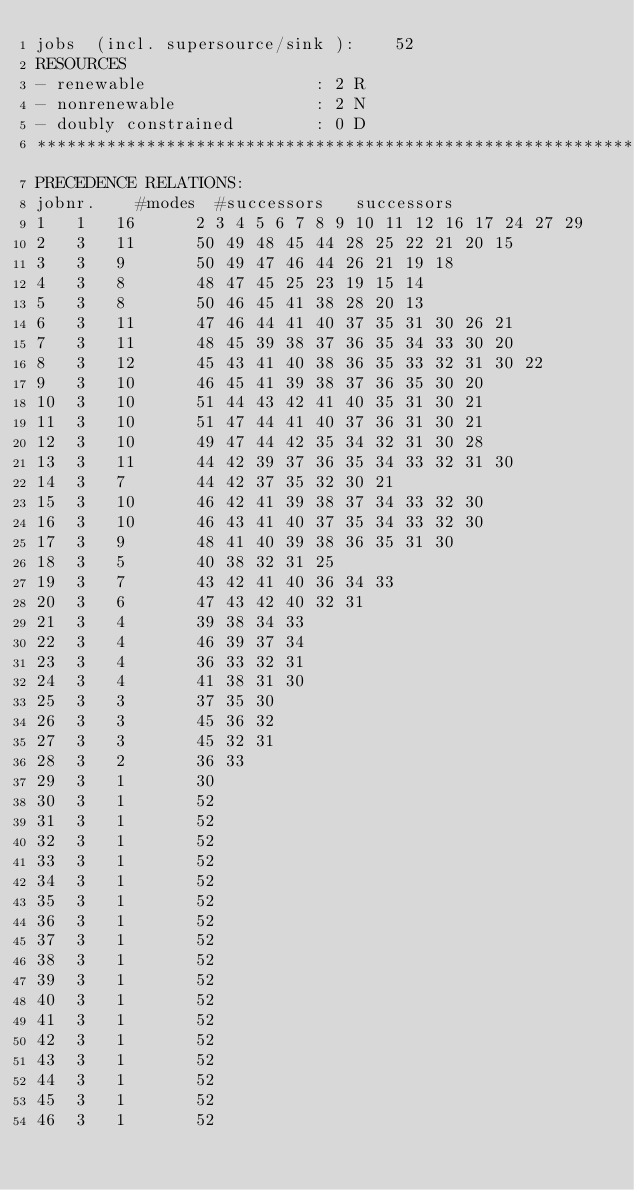<code> <loc_0><loc_0><loc_500><loc_500><_ObjectiveC_>jobs  (incl. supersource/sink ):	52
RESOURCES
- renewable                 : 2 R
- nonrenewable              : 2 N
- doubly constrained        : 0 D
************************************************************************
PRECEDENCE RELATIONS:
jobnr.    #modes  #successors   successors
1	1	16		2 3 4 5 6 7 8 9 10 11 12 16 17 24 27 29 
2	3	11		50 49 48 45 44 28 25 22 21 20 15 
3	3	9		50 49 47 46 44 26 21 19 18 
4	3	8		48 47 45 25 23 19 15 14 
5	3	8		50 46 45 41 38 28 20 13 
6	3	11		47 46 44 41 40 37 35 31 30 26 21 
7	3	11		48 45 39 38 37 36 35 34 33 30 20 
8	3	12		45 43 41 40 38 36 35 33 32 31 30 22 
9	3	10		46 45 41 39 38 37 36 35 30 20 
10	3	10		51 44 43 42 41 40 35 31 30 21 
11	3	10		51 47 44 41 40 37 36 31 30 21 
12	3	10		49 47 44 42 35 34 32 31 30 28 
13	3	11		44 42 39 37 36 35 34 33 32 31 30 
14	3	7		44 42 37 35 32 30 21 
15	3	10		46 42 41 39 38 37 34 33 32 30 
16	3	10		46 43 41 40 37 35 34 33 32 30 
17	3	9		48 41 40 39 38 36 35 31 30 
18	3	5		40 38 32 31 25 
19	3	7		43 42 41 40 36 34 33 
20	3	6		47 43 42 40 32 31 
21	3	4		39 38 34 33 
22	3	4		46 39 37 34 
23	3	4		36 33 32 31 
24	3	4		41 38 31 30 
25	3	3		37 35 30 
26	3	3		45 36 32 
27	3	3		45 32 31 
28	3	2		36 33 
29	3	1		30 
30	3	1		52 
31	3	1		52 
32	3	1		52 
33	3	1		52 
34	3	1		52 
35	3	1		52 
36	3	1		52 
37	3	1		52 
38	3	1		52 
39	3	1		52 
40	3	1		52 
41	3	1		52 
42	3	1		52 
43	3	1		52 
44	3	1		52 
45	3	1		52 
46	3	1		52 </code> 